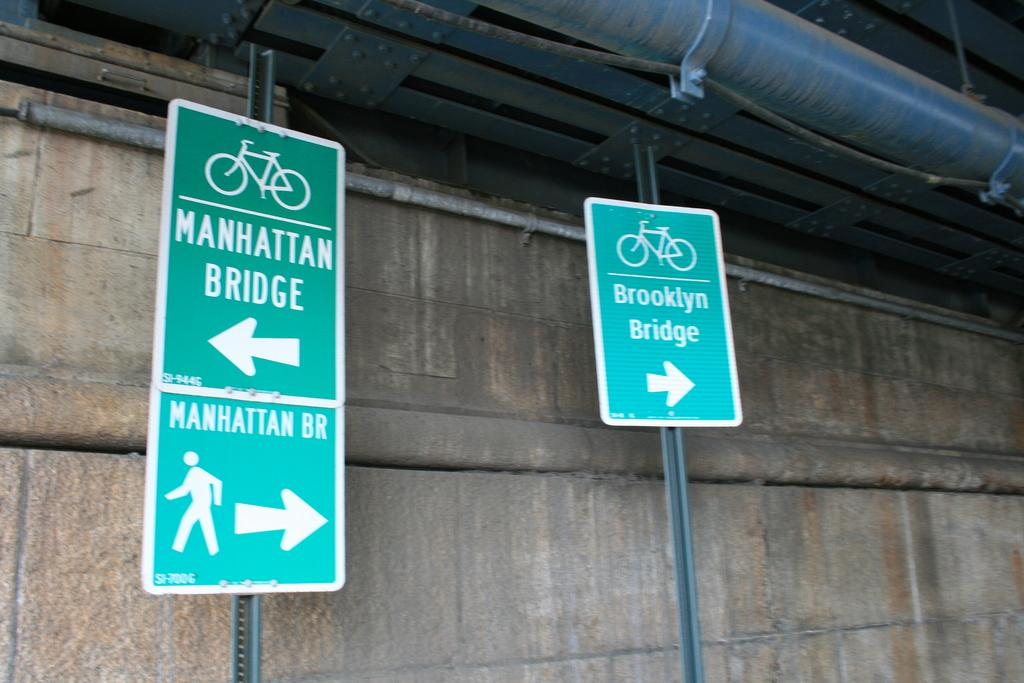Provide a one-sentence caption for the provided image. a sign reading brooklyn bridge sits on the right. 